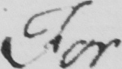Please transcribe the handwritten text in this image. For 